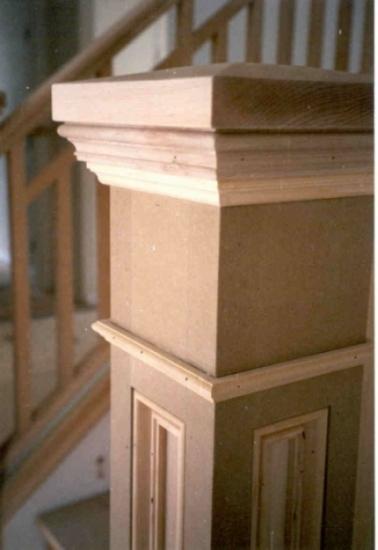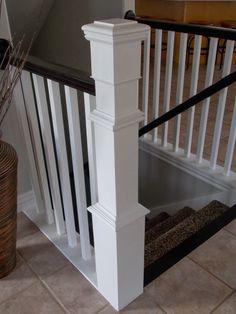The first image is the image on the left, the second image is the image on the right. For the images shown, is this caption "there is a srairway being shown from the top floor, the rails are white and the top rail is painted black" true? Answer yes or no. Yes. The first image is the image on the left, the second image is the image on the right. Given the left and right images, does the statement "In one image, at least one newel post is at the bottom of stairs, but in the second image, two newel posts are at the top of stairs." hold true? Answer yes or no. No. 